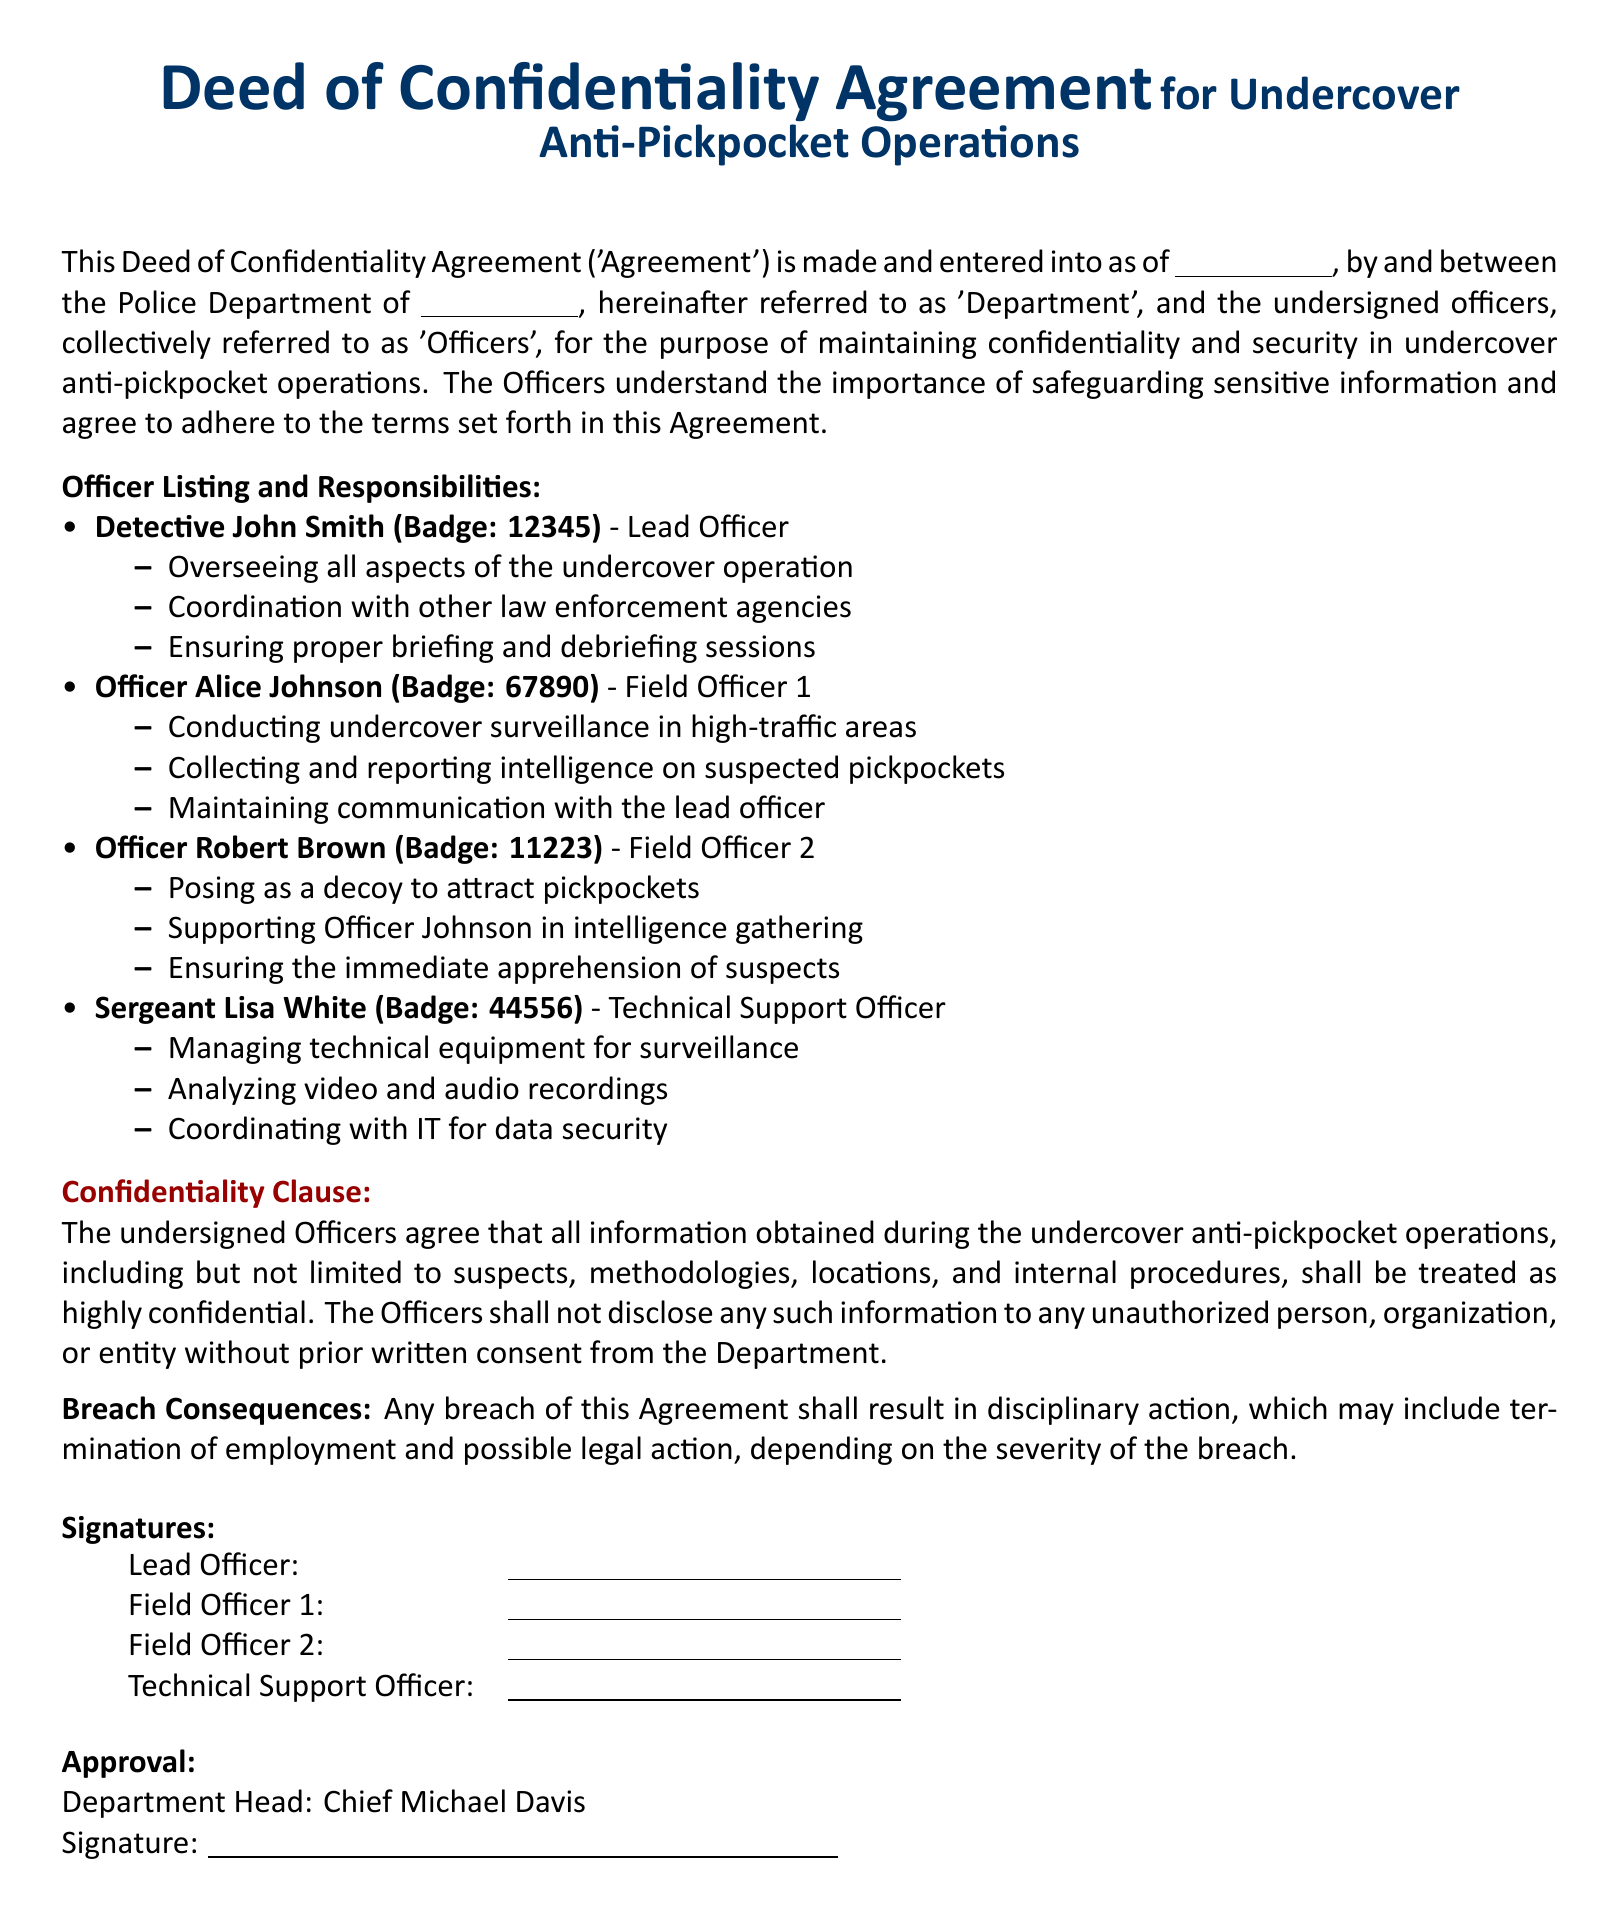What is the title of the document? The title is prominently displayed at the top of the document, indicating its purpose.
Answer: Deed of Confidentiality Agreement Who is the lead officer? The lead officer's name is listed under the Officer Listing and Responsibilities section.
Answer: Detective John Smith What is Officer Alice Johnson's badge number? Badge numbers are provided next to each officer's name in the document.
Answer: 67890 What role does Sergeant Lisa White hold? Each officer's specific role is mentioned alongside their name in the listing.
Answer: Technical Support Officer What are the consequences of breaching the agreement? The document specifies the potential outcomes for breach within the Breach Consequences section.
Answer: Disciplinary action How many field officers are mentioned in the document? The document lists the number of field officers within the Officer Listing and Responsibilities section.
Answer: Two What must officers do before disclosing confidential information? The confidentiality clause states the requirement for disclosure authorization.
Answer: Obtain prior written consent Who is the Department Head? The document lists the name of the individual who is responsible for approving the agreement.
Answer: Chief Michael Davis 